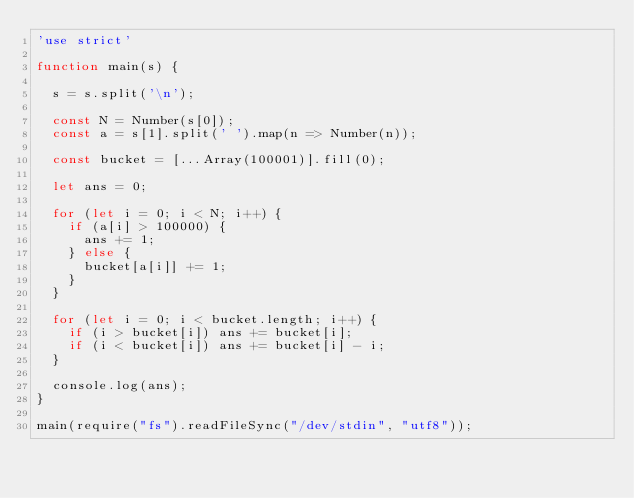Convert code to text. <code><loc_0><loc_0><loc_500><loc_500><_JavaScript_>'use strict'

function main(s) {

  s = s.split('\n');

  const N = Number(s[0]);
  const a = s[1].split(' ').map(n => Number(n));

  const bucket = [...Array(100001)].fill(0);

  let ans = 0;

  for (let i = 0; i < N; i++) {
    if (a[i] > 100000) {
      ans += 1;
    } else {
      bucket[a[i]] += 1;
    }
  }

  for (let i = 0; i < bucket.length; i++) {
    if (i > bucket[i]) ans += bucket[i];
    if (i < bucket[i]) ans += bucket[i] - i;
  }

  console.log(ans);
}

main(require("fs").readFileSync("/dev/stdin", "utf8"));
</code> 